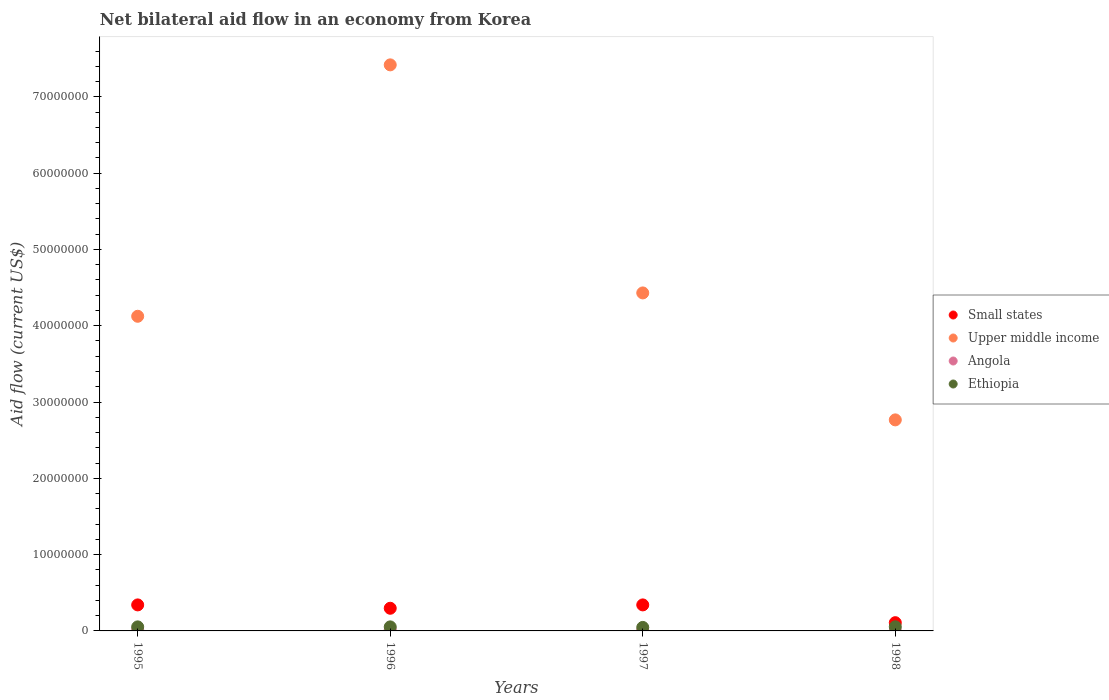Is the number of dotlines equal to the number of legend labels?
Ensure brevity in your answer.  Yes. Across all years, what is the maximum net bilateral aid flow in Ethiopia?
Your response must be concise. 5.40e+05. Across all years, what is the minimum net bilateral aid flow in Upper middle income?
Your response must be concise. 2.77e+07. In which year was the net bilateral aid flow in Small states maximum?
Provide a short and direct response. 1995. In which year was the net bilateral aid flow in Small states minimum?
Offer a very short reply. 1998. What is the total net bilateral aid flow in Angola in the graph?
Provide a succinct answer. 4.00e+05. What is the difference between the net bilateral aid flow in Upper middle income in 1996 and that in 1998?
Keep it short and to the point. 4.65e+07. What is the difference between the net bilateral aid flow in Ethiopia in 1997 and the net bilateral aid flow in Small states in 1995?
Make the answer very short. -2.95e+06. What is the average net bilateral aid flow in Upper middle income per year?
Your response must be concise. 4.68e+07. In the year 1996, what is the difference between the net bilateral aid flow in Ethiopia and net bilateral aid flow in Angola?
Provide a short and direct response. 3.80e+05. In how many years, is the net bilateral aid flow in Ethiopia greater than 30000000 US$?
Your response must be concise. 0. What is the ratio of the net bilateral aid flow in Small states in 1996 to that in 1997?
Your answer should be compact. 0.87. Is the net bilateral aid flow in Small states in 1996 less than that in 1998?
Give a very brief answer. No. What is the difference between the highest and the second highest net bilateral aid flow in Upper middle income?
Give a very brief answer. 2.99e+07. What is the difference between the highest and the lowest net bilateral aid flow in Upper middle income?
Ensure brevity in your answer.  4.65e+07. In how many years, is the net bilateral aid flow in Small states greater than the average net bilateral aid flow in Small states taken over all years?
Ensure brevity in your answer.  3. Is the sum of the net bilateral aid flow in Ethiopia in 1995 and 1996 greater than the maximum net bilateral aid flow in Angola across all years?
Offer a terse response. Yes. Is the net bilateral aid flow in Upper middle income strictly greater than the net bilateral aid flow in Angola over the years?
Your response must be concise. Yes. How many years are there in the graph?
Your answer should be compact. 4. Does the graph contain grids?
Provide a short and direct response. No. Where does the legend appear in the graph?
Your answer should be compact. Center right. How many legend labels are there?
Keep it short and to the point. 4. How are the legend labels stacked?
Provide a short and direct response. Vertical. What is the title of the graph?
Offer a terse response. Net bilateral aid flow in an economy from Korea. Does "Turkmenistan" appear as one of the legend labels in the graph?
Make the answer very short. No. What is the label or title of the Y-axis?
Keep it short and to the point. Aid flow (current US$). What is the Aid flow (current US$) in Small states in 1995?
Your answer should be compact. 3.41e+06. What is the Aid flow (current US$) in Upper middle income in 1995?
Keep it short and to the point. 4.12e+07. What is the Aid flow (current US$) in Ethiopia in 1995?
Give a very brief answer. 5.30e+05. What is the Aid flow (current US$) in Small states in 1996?
Give a very brief answer. 2.97e+06. What is the Aid flow (current US$) in Upper middle income in 1996?
Ensure brevity in your answer.  7.42e+07. What is the Aid flow (current US$) of Ethiopia in 1996?
Provide a short and direct response. 5.30e+05. What is the Aid flow (current US$) of Small states in 1997?
Keep it short and to the point. 3.41e+06. What is the Aid flow (current US$) in Upper middle income in 1997?
Offer a very short reply. 4.43e+07. What is the Aid flow (current US$) in Angola in 1997?
Make the answer very short. 9.00e+04. What is the Aid flow (current US$) in Small states in 1998?
Provide a short and direct response. 1.08e+06. What is the Aid flow (current US$) of Upper middle income in 1998?
Keep it short and to the point. 2.77e+07. What is the Aid flow (current US$) of Angola in 1998?
Your response must be concise. 2.00e+04. What is the Aid flow (current US$) of Ethiopia in 1998?
Make the answer very short. 5.40e+05. Across all years, what is the maximum Aid flow (current US$) of Small states?
Offer a very short reply. 3.41e+06. Across all years, what is the maximum Aid flow (current US$) of Upper middle income?
Provide a succinct answer. 7.42e+07. Across all years, what is the maximum Aid flow (current US$) in Angola?
Provide a short and direct response. 1.50e+05. Across all years, what is the maximum Aid flow (current US$) of Ethiopia?
Offer a very short reply. 5.40e+05. Across all years, what is the minimum Aid flow (current US$) in Small states?
Ensure brevity in your answer.  1.08e+06. Across all years, what is the minimum Aid flow (current US$) in Upper middle income?
Provide a succinct answer. 2.77e+07. Across all years, what is the minimum Aid flow (current US$) of Angola?
Ensure brevity in your answer.  2.00e+04. What is the total Aid flow (current US$) in Small states in the graph?
Your answer should be compact. 1.09e+07. What is the total Aid flow (current US$) of Upper middle income in the graph?
Provide a succinct answer. 1.87e+08. What is the total Aid flow (current US$) in Ethiopia in the graph?
Your response must be concise. 2.06e+06. What is the difference between the Aid flow (current US$) in Upper middle income in 1995 and that in 1996?
Provide a succinct answer. -3.30e+07. What is the difference between the Aid flow (current US$) of Small states in 1995 and that in 1997?
Keep it short and to the point. 0. What is the difference between the Aid flow (current US$) in Upper middle income in 1995 and that in 1997?
Give a very brief answer. -3.06e+06. What is the difference between the Aid flow (current US$) of Angola in 1995 and that in 1997?
Offer a very short reply. 5.00e+04. What is the difference between the Aid flow (current US$) of Small states in 1995 and that in 1998?
Ensure brevity in your answer.  2.33e+06. What is the difference between the Aid flow (current US$) of Upper middle income in 1995 and that in 1998?
Ensure brevity in your answer.  1.36e+07. What is the difference between the Aid flow (current US$) in Ethiopia in 1995 and that in 1998?
Offer a very short reply. -10000. What is the difference between the Aid flow (current US$) in Small states in 1996 and that in 1997?
Make the answer very short. -4.40e+05. What is the difference between the Aid flow (current US$) of Upper middle income in 1996 and that in 1997?
Make the answer very short. 2.99e+07. What is the difference between the Aid flow (current US$) in Angola in 1996 and that in 1997?
Make the answer very short. 6.00e+04. What is the difference between the Aid flow (current US$) of Small states in 1996 and that in 1998?
Your response must be concise. 1.89e+06. What is the difference between the Aid flow (current US$) of Upper middle income in 1996 and that in 1998?
Ensure brevity in your answer.  4.65e+07. What is the difference between the Aid flow (current US$) in Angola in 1996 and that in 1998?
Offer a terse response. 1.30e+05. What is the difference between the Aid flow (current US$) in Ethiopia in 1996 and that in 1998?
Give a very brief answer. -10000. What is the difference between the Aid flow (current US$) of Small states in 1997 and that in 1998?
Your response must be concise. 2.33e+06. What is the difference between the Aid flow (current US$) in Upper middle income in 1997 and that in 1998?
Your response must be concise. 1.66e+07. What is the difference between the Aid flow (current US$) of Ethiopia in 1997 and that in 1998?
Give a very brief answer. -8.00e+04. What is the difference between the Aid flow (current US$) in Small states in 1995 and the Aid flow (current US$) in Upper middle income in 1996?
Offer a very short reply. -7.08e+07. What is the difference between the Aid flow (current US$) in Small states in 1995 and the Aid flow (current US$) in Angola in 1996?
Make the answer very short. 3.26e+06. What is the difference between the Aid flow (current US$) of Small states in 1995 and the Aid flow (current US$) of Ethiopia in 1996?
Ensure brevity in your answer.  2.88e+06. What is the difference between the Aid flow (current US$) of Upper middle income in 1995 and the Aid flow (current US$) of Angola in 1996?
Provide a short and direct response. 4.11e+07. What is the difference between the Aid flow (current US$) in Upper middle income in 1995 and the Aid flow (current US$) in Ethiopia in 1996?
Provide a short and direct response. 4.07e+07. What is the difference between the Aid flow (current US$) of Angola in 1995 and the Aid flow (current US$) of Ethiopia in 1996?
Offer a very short reply. -3.90e+05. What is the difference between the Aid flow (current US$) of Small states in 1995 and the Aid flow (current US$) of Upper middle income in 1997?
Offer a very short reply. -4.09e+07. What is the difference between the Aid flow (current US$) of Small states in 1995 and the Aid flow (current US$) of Angola in 1997?
Ensure brevity in your answer.  3.32e+06. What is the difference between the Aid flow (current US$) in Small states in 1995 and the Aid flow (current US$) in Ethiopia in 1997?
Provide a succinct answer. 2.95e+06. What is the difference between the Aid flow (current US$) in Upper middle income in 1995 and the Aid flow (current US$) in Angola in 1997?
Offer a very short reply. 4.12e+07. What is the difference between the Aid flow (current US$) of Upper middle income in 1995 and the Aid flow (current US$) of Ethiopia in 1997?
Give a very brief answer. 4.08e+07. What is the difference between the Aid flow (current US$) of Angola in 1995 and the Aid flow (current US$) of Ethiopia in 1997?
Provide a short and direct response. -3.20e+05. What is the difference between the Aid flow (current US$) in Small states in 1995 and the Aid flow (current US$) in Upper middle income in 1998?
Provide a short and direct response. -2.42e+07. What is the difference between the Aid flow (current US$) in Small states in 1995 and the Aid flow (current US$) in Angola in 1998?
Ensure brevity in your answer.  3.39e+06. What is the difference between the Aid flow (current US$) of Small states in 1995 and the Aid flow (current US$) of Ethiopia in 1998?
Your answer should be very brief. 2.87e+06. What is the difference between the Aid flow (current US$) of Upper middle income in 1995 and the Aid flow (current US$) of Angola in 1998?
Give a very brief answer. 4.12e+07. What is the difference between the Aid flow (current US$) in Upper middle income in 1995 and the Aid flow (current US$) in Ethiopia in 1998?
Your response must be concise. 4.07e+07. What is the difference between the Aid flow (current US$) in Angola in 1995 and the Aid flow (current US$) in Ethiopia in 1998?
Provide a succinct answer. -4.00e+05. What is the difference between the Aid flow (current US$) of Small states in 1996 and the Aid flow (current US$) of Upper middle income in 1997?
Give a very brief answer. -4.13e+07. What is the difference between the Aid flow (current US$) of Small states in 1996 and the Aid flow (current US$) of Angola in 1997?
Give a very brief answer. 2.88e+06. What is the difference between the Aid flow (current US$) of Small states in 1996 and the Aid flow (current US$) of Ethiopia in 1997?
Provide a succinct answer. 2.51e+06. What is the difference between the Aid flow (current US$) of Upper middle income in 1996 and the Aid flow (current US$) of Angola in 1997?
Your response must be concise. 7.41e+07. What is the difference between the Aid flow (current US$) in Upper middle income in 1996 and the Aid flow (current US$) in Ethiopia in 1997?
Your response must be concise. 7.37e+07. What is the difference between the Aid flow (current US$) in Angola in 1996 and the Aid flow (current US$) in Ethiopia in 1997?
Give a very brief answer. -3.10e+05. What is the difference between the Aid flow (current US$) in Small states in 1996 and the Aid flow (current US$) in Upper middle income in 1998?
Your answer should be very brief. -2.47e+07. What is the difference between the Aid flow (current US$) in Small states in 1996 and the Aid flow (current US$) in Angola in 1998?
Ensure brevity in your answer.  2.95e+06. What is the difference between the Aid flow (current US$) in Small states in 1996 and the Aid flow (current US$) in Ethiopia in 1998?
Provide a succinct answer. 2.43e+06. What is the difference between the Aid flow (current US$) of Upper middle income in 1996 and the Aid flow (current US$) of Angola in 1998?
Provide a short and direct response. 7.42e+07. What is the difference between the Aid flow (current US$) of Upper middle income in 1996 and the Aid flow (current US$) of Ethiopia in 1998?
Offer a very short reply. 7.36e+07. What is the difference between the Aid flow (current US$) in Angola in 1996 and the Aid flow (current US$) in Ethiopia in 1998?
Provide a short and direct response. -3.90e+05. What is the difference between the Aid flow (current US$) in Small states in 1997 and the Aid flow (current US$) in Upper middle income in 1998?
Your answer should be compact. -2.42e+07. What is the difference between the Aid flow (current US$) in Small states in 1997 and the Aid flow (current US$) in Angola in 1998?
Your answer should be very brief. 3.39e+06. What is the difference between the Aid flow (current US$) of Small states in 1997 and the Aid flow (current US$) of Ethiopia in 1998?
Provide a succinct answer. 2.87e+06. What is the difference between the Aid flow (current US$) in Upper middle income in 1997 and the Aid flow (current US$) in Angola in 1998?
Give a very brief answer. 4.43e+07. What is the difference between the Aid flow (current US$) in Upper middle income in 1997 and the Aid flow (current US$) in Ethiopia in 1998?
Ensure brevity in your answer.  4.38e+07. What is the difference between the Aid flow (current US$) of Angola in 1997 and the Aid flow (current US$) of Ethiopia in 1998?
Make the answer very short. -4.50e+05. What is the average Aid flow (current US$) in Small states per year?
Offer a very short reply. 2.72e+06. What is the average Aid flow (current US$) of Upper middle income per year?
Your answer should be very brief. 4.68e+07. What is the average Aid flow (current US$) in Ethiopia per year?
Your response must be concise. 5.15e+05. In the year 1995, what is the difference between the Aid flow (current US$) of Small states and Aid flow (current US$) of Upper middle income?
Ensure brevity in your answer.  -3.78e+07. In the year 1995, what is the difference between the Aid flow (current US$) in Small states and Aid flow (current US$) in Angola?
Keep it short and to the point. 3.27e+06. In the year 1995, what is the difference between the Aid flow (current US$) of Small states and Aid flow (current US$) of Ethiopia?
Provide a succinct answer. 2.88e+06. In the year 1995, what is the difference between the Aid flow (current US$) of Upper middle income and Aid flow (current US$) of Angola?
Provide a short and direct response. 4.11e+07. In the year 1995, what is the difference between the Aid flow (current US$) of Upper middle income and Aid flow (current US$) of Ethiopia?
Offer a terse response. 4.07e+07. In the year 1995, what is the difference between the Aid flow (current US$) of Angola and Aid flow (current US$) of Ethiopia?
Your answer should be compact. -3.90e+05. In the year 1996, what is the difference between the Aid flow (current US$) in Small states and Aid flow (current US$) in Upper middle income?
Your answer should be compact. -7.12e+07. In the year 1996, what is the difference between the Aid flow (current US$) in Small states and Aid flow (current US$) in Angola?
Keep it short and to the point. 2.82e+06. In the year 1996, what is the difference between the Aid flow (current US$) in Small states and Aid flow (current US$) in Ethiopia?
Make the answer very short. 2.44e+06. In the year 1996, what is the difference between the Aid flow (current US$) in Upper middle income and Aid flow (current US$) in Angola?
Your answer should be compact. 7.40e+07. In the year 1996, what is the difference between the Aid flow (current US$) in Upper middle income and Aid flow (current US$) in Ethiopia?
Provide a short and direct response. 7.37e+07. In the year 1996, what is the difference between the Aid flow (current US$) of Angola and Aid flow (current US$) of Ethiopia?
Provide a short and direct response. -3.80e+05. In the year 1997, what is the difference between the Aid flow (current US$) of Small states and Aid flow (current US$) of Upper middle income?
Give a very brief answer. -4.09e+07. In the year 1997, what is the difference between the Aid flow (current US$) in Small states and Aid flow (current US$) in Angola?
Offer a very short reply. 3.32e+06. In the year 1997, what is the difference between the Aid flow (current US$) in Small states and Aid flow (current US$) in Ethiopia?
Make the answer very short. 2.95e+06. In the year 1997, what is the difference between the Aid flow (current US$) in Upper middle income and Aid flow (current US$) in Angola?
Your response must be concise. 4.42e+07. In the year 1997, what is the difference between the Aid flow (current US$) of Upper middle income and Aid flow (current US$) of Ethiopia?
Provide a short and direct response. 4.38e+07. In the year 1997, what is the difference between the Aid flow (current US$) of Angola and Aid flow (current US$) of Ethiopia?
Provide a succinct answer. -3.70e+05. In the year 1998, what is the difference between the Aid flow (current US$) of Small states and Aid flow (current US$) of Upper middle income?
Give a very brief answer. -2.66e+07. In the year 1998, what is the difference between the Aid flow (current US$) in Small states and Aid flow (current US$) in Angola?
Offer a very short reply. 1.06e+06. In the year 1998, what is the difference between the Aid flow (current US$) of Small states and Aid flow (current US$) of Ethiopia?
Provide a succinct answer. 5.40e+05. In the year 1998, what is the difference between the Aid flow (current US$) of Upper middle income and Aid flow (current US$) of Angola?
Offer a very short reply. 2.76e+07. In the year 1998, what is the difference between the Aid flow (current US$) in Upper middle income and Aid flow (current US$) in Ethiopia?
Your answer should be very brief. 2.71e+07. In the year 1998, what is the difference between the Aid flow (current US$) in Angola and Aid flow (current US$) in Ethiopia?
Ensure brevity in your answer.  -5.20e+05. What is the ratio of the Aid flow (current US$) in Small states in 1995 to that in 1996?
Your response must be concise. 1.15. What is the ratio of the Aid flow (current US$) in Upper middle income in 1995 to that in 1996?
Keep it short and to the point. 0.56. What is the ratio of the Aid flow (current US$) in Ethiopia in 1995 to that in 1996?
Give a very brief answer. 1. What is the ratio of the Aid flow (current US$) of Small states in 1995 to that in 1997?
Offer a terse response. 1. What is the ratio of the Aid flow (current US$) in Upper middle income in 1995 to that in 1997?
Offer a terse response. 0.93. What is the ratio of the Aid flow (current US$) of Angola in 1995 to that in 1997?
Offer a terse response. 1.56. What is the ratio of the Aid flow (current US$) of Ethiopia in 1995 to that in 1997?
Make the answer very short. 1.15. What is the ratio of the Aid flow (current US$) in Small states in 1995 to that in 1998?
Your answer should be compact. 3.16. What is the ratio of the Aid flow (current US$) in Upper middle income in 1995 to that in 1998?
Your response must be concise. 1.49. What is the ratio of the Aid flow (current US$) in Angola in 1995 to that in 1998?
Give a very brief answer. 7. What is the ratio of the Aid flow (current US$) in Ethiopia in 1995 to that in 1998?
Keep it short and to the point. 0.98. What is the ratio of the Aid flow (current US$) of Small states in 1996 to that in 1997?
Your answer should be very brief. 0.87. What is the ratio of the Aid flow (current US$) in Upper middle income in 1996 to that in 1997?
Your answer should be very brief. 1.67. What is the ratio of the Aid flow (current US$) in Ethiopia in 1996 to that in 1997?
Give a very brief answer. 1.15. What is the ratio of the Aid flow (current US$) of Small states in 1996 to that in 1998?
Offer a very short reply. 2.75. What is the ratio of the Aid flow (current US$) of Upper middle income in 1996 to that in 1998?
Your answer should be compact. 2.68. What is the ratio of the Aid flow (current US$) of Ethiopia in 1996 to that in 1998?
Provide a succinct answer. 0.98. What is the ratio of the Aid flow (current US$) of Small states in 1997 to that in 1998?
Your answer should be compact. 3.16. What is the ratio of the Aid flow (current US$) in Upper middle income in 1997 to that in 1998?
Make the answer very short. 1.6. What is the ratio of the Aid flow (current US$) in Angola in 1997 to that in 1998?
Your answer should be compact. 4.5. What is the ratio of the Aid flow (current US$) in Ethiopia in 1997 to that in 1998?
Ensure brevity in your answer.  0.85. What is the difference between the highest and the second highest Aid flow (current US$) of Small states?
Offer a very short reply. 0. What is the difference between the highest and the second highest Aid flow (current US$) in Upper middle income?
Provide a short and direct response. 2.99e+07. What is the difference between the highest and the second highest Aid flow (current US$) in Angola?
Provide a succinct answer. 10000. What is the difference between the highest and the lowest Aid flow (current US$) of Small states?
Your answer should be very brief. 2.33e+06. What is the difference between the highest and the lowest Aid flow (current US$) in Upper middle income?
Provide a short and direct response. 4.65e+07. What is the difference between the highest and the lowest Aid flow (current US$) in Angola?
Provide a short and direct response. 1.30e+05. What is the difference between the highest and the lowest Aid flow (current US$) of Ethiopia?
Your answer should be very brief. 8.00e+04. 